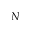Convert formula to latex. <formula><loc_0><loc_0><loc_500><loc_500>N</formula> 